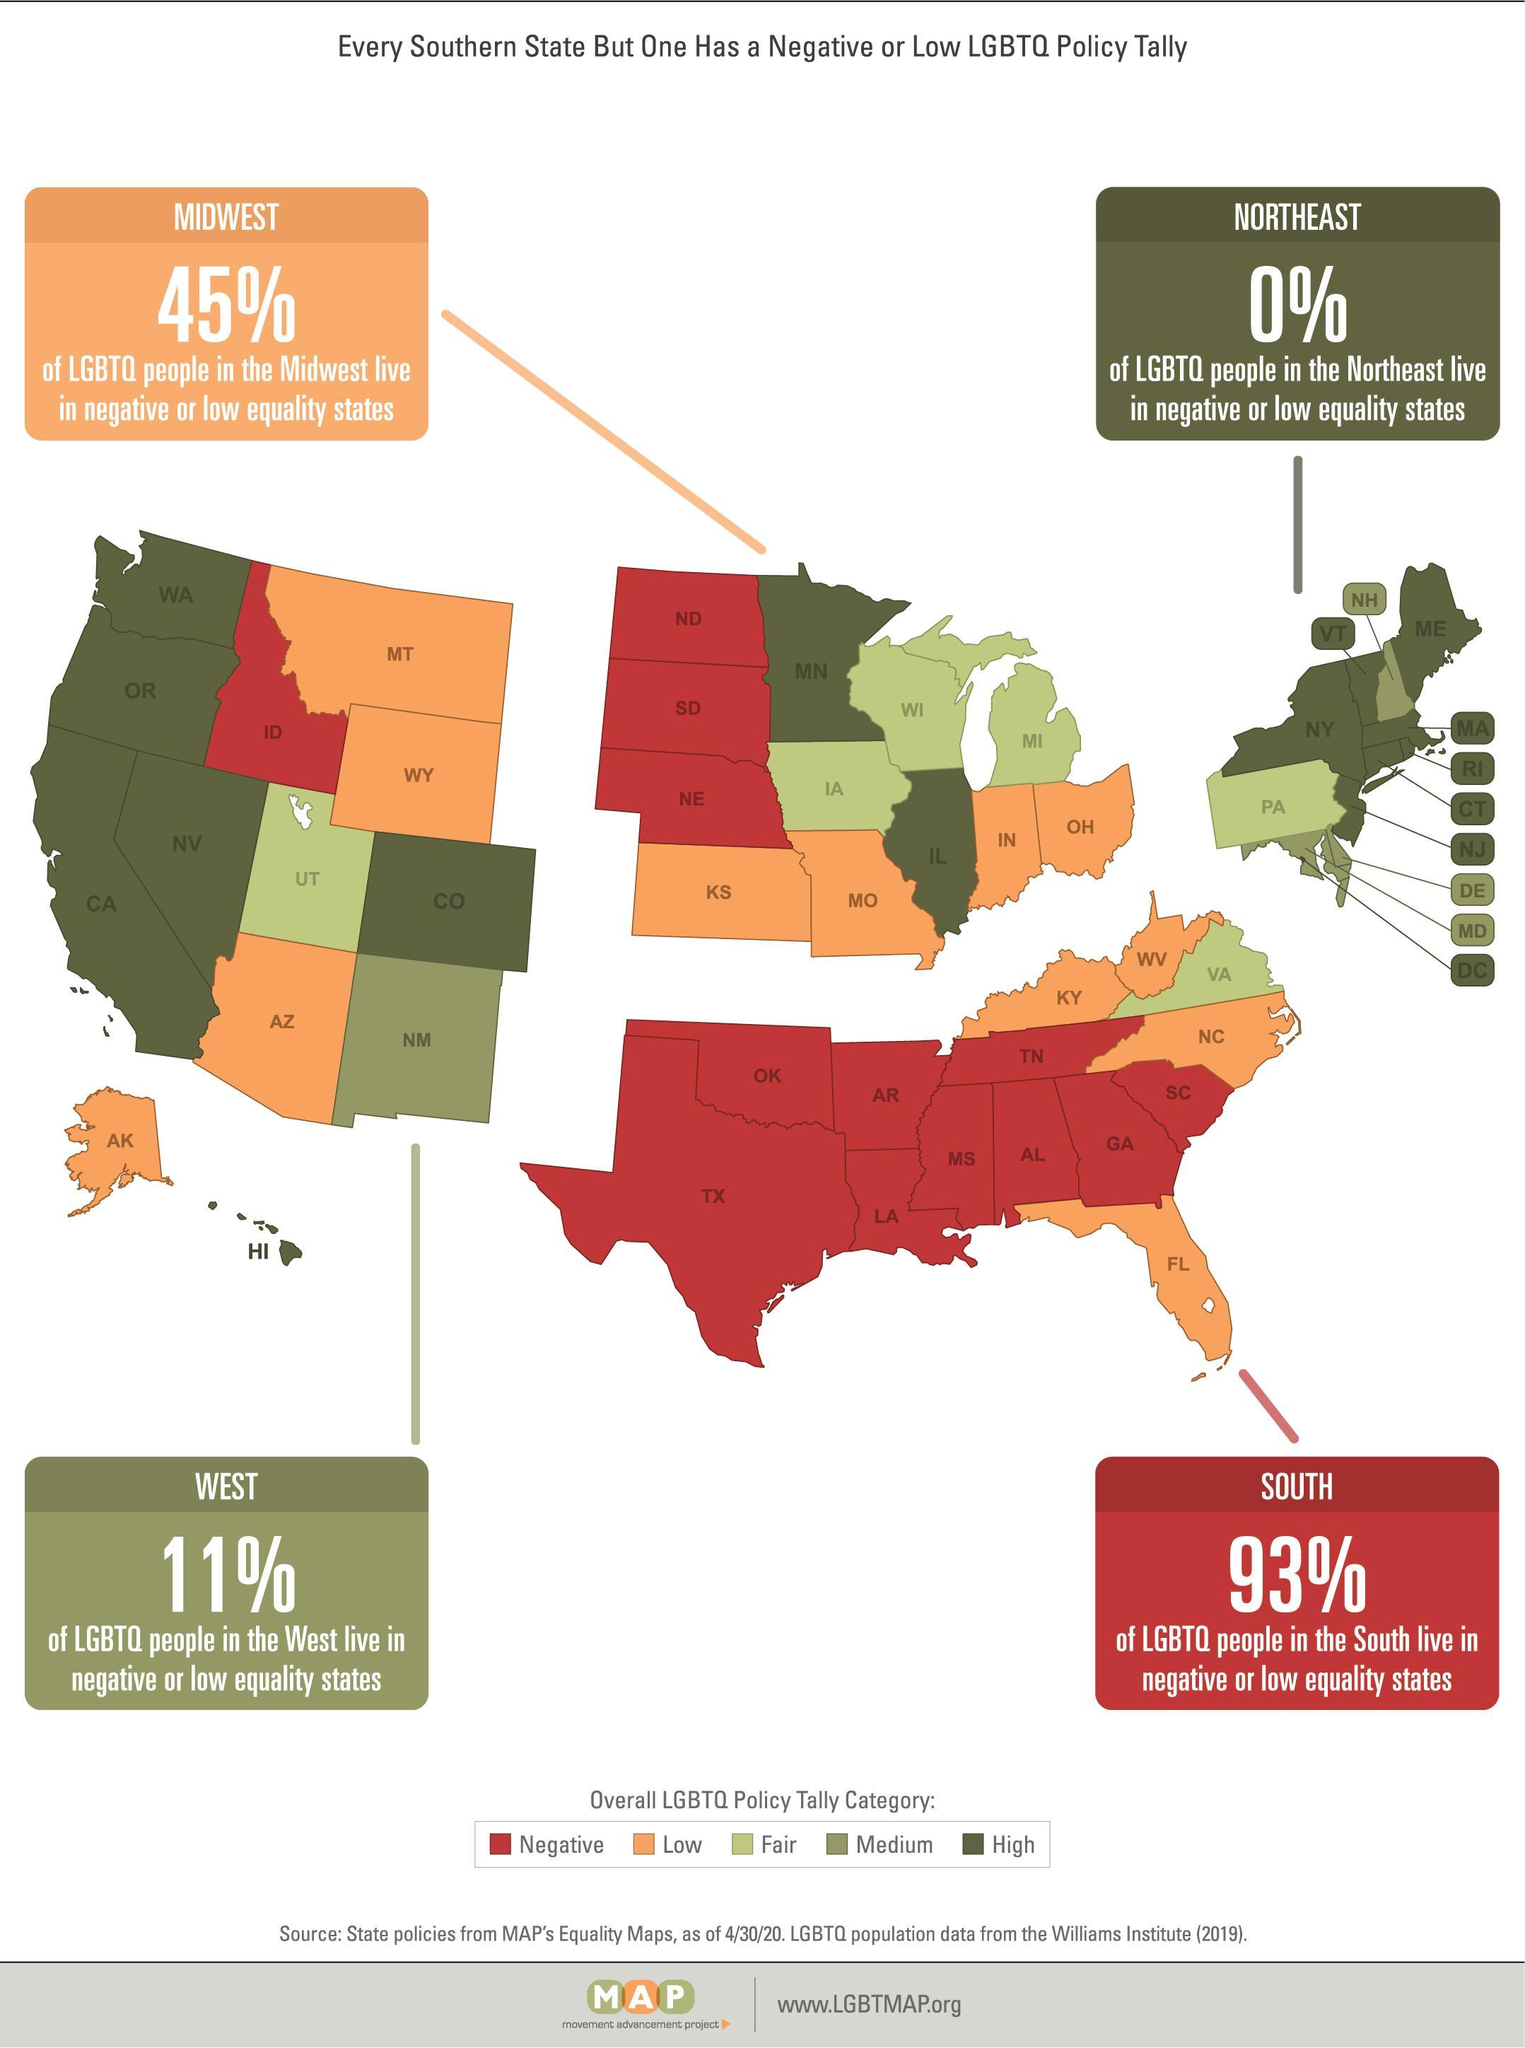How many states are in Low LGBTQ?
Answer the question with a short phrase. 12 Which is the exceptional southern state which has no low or negative LGBTQ Policy tally? VA How many states are in Negative LGBTQ? 13 How many states have Medium LGBTQ Policy Tally? 4 How many states are in Fair LGBTQ? 6 What is the LGBTQ Policy Tally of the state Alaska AK? Low What percentage of people in Midwest live in negative or low equality states? 45% What percentage of people in Northeast live in negative or low equality states? 0% What percentage of LGBTQ people in South do not live in negative or low equality states? 7 What percentage of LGBTQ people in West do not live in negative or low equality states? 89 